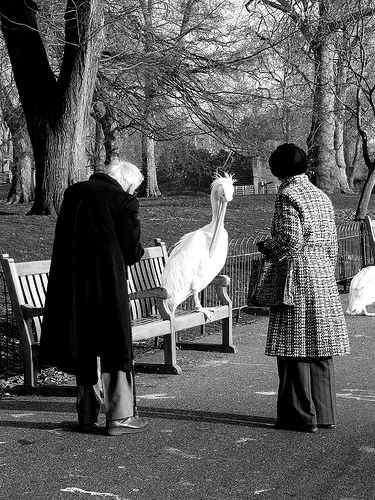Please provide a short description for this region: [0.65, 0.35, 0.82, 0.71]. A woman is wearing a long black and white coat. 